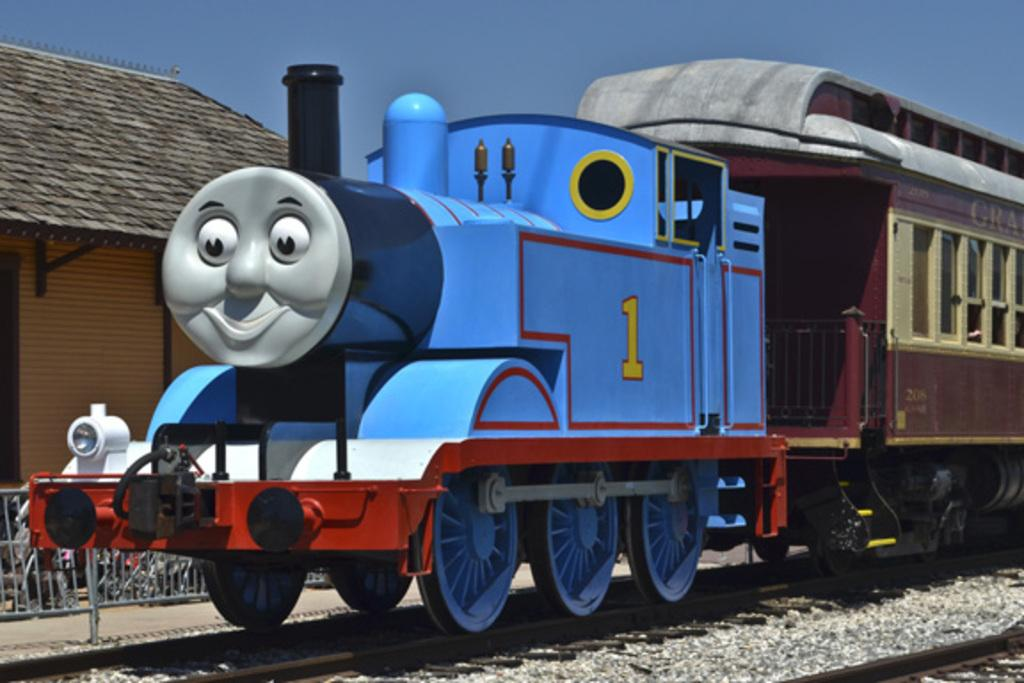<image>
Present a compact description of the photo's key features. A blue Thomas the Train engine with the number 1 on the side. 